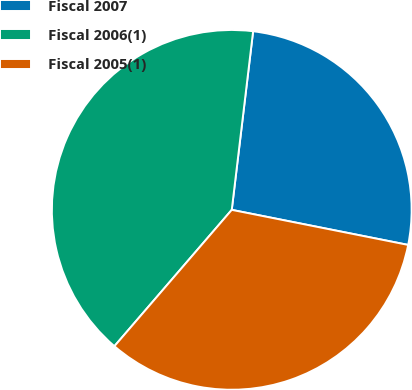Convert chart. <chart><loc_0><loc_0><loc_500><loc_500><pie_chart><fcel>Fiscal 2007<fcel>Fiscal 2006(1)<fcel>Fiscal 2005(1)<nl><fcel>26.23%<fcel>40.59%<fcel>33.19%<nl></chart> 